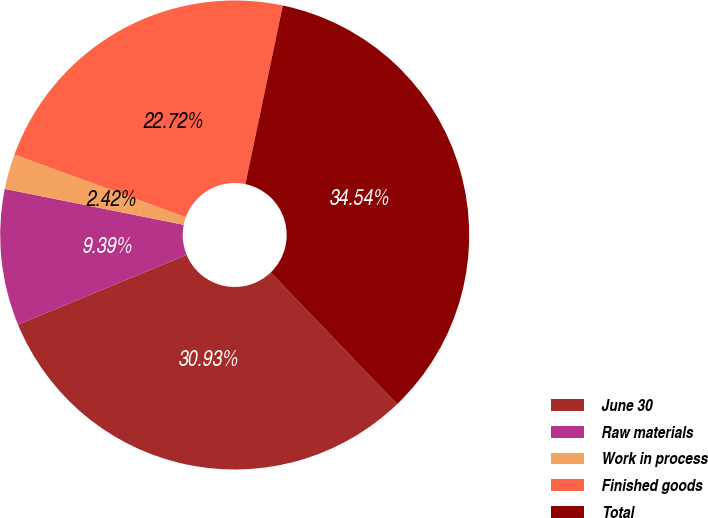Convert chart. <chart><loc_0><loc_0><loc_500><loc_500><pie_chart><fcel>June 30<fcel>Raw materials<fcel>Work in process<fcel>Finished goods<fcel>Total<nl><fcel>30.93%<fcel>9.39%<fcel>2.42%<fcel>22.72%<fcel>34.54%<nl></chart> 